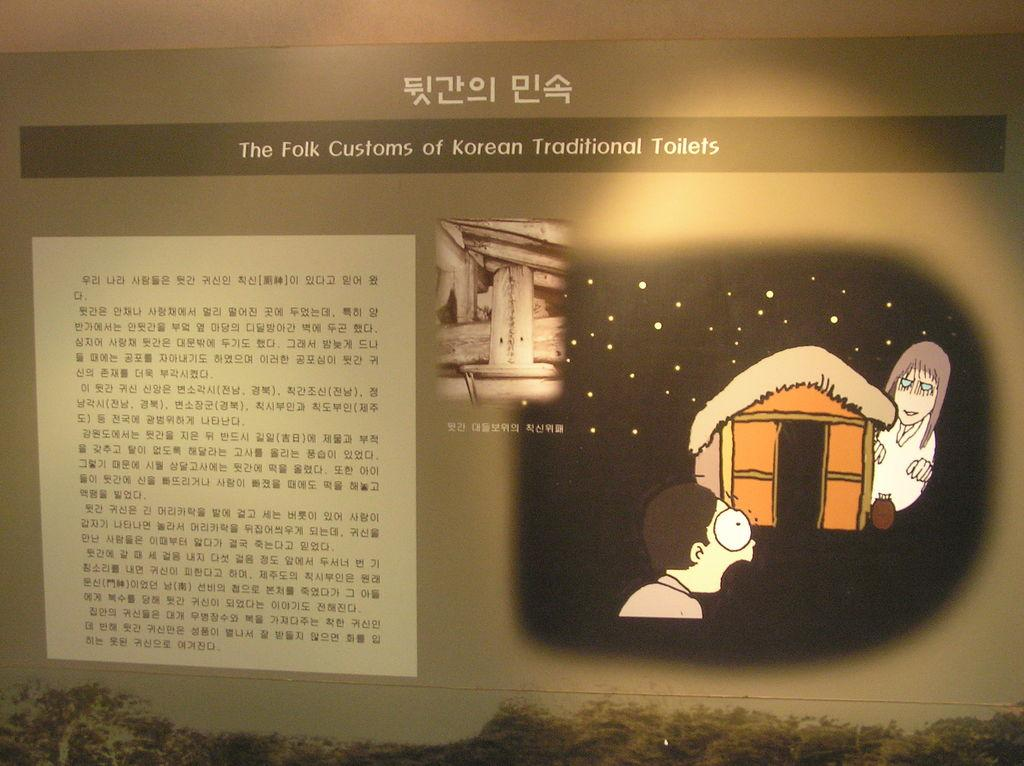<image>
Describe the image concisely. A display discusses the folk customs of Korean traditional toilets. 